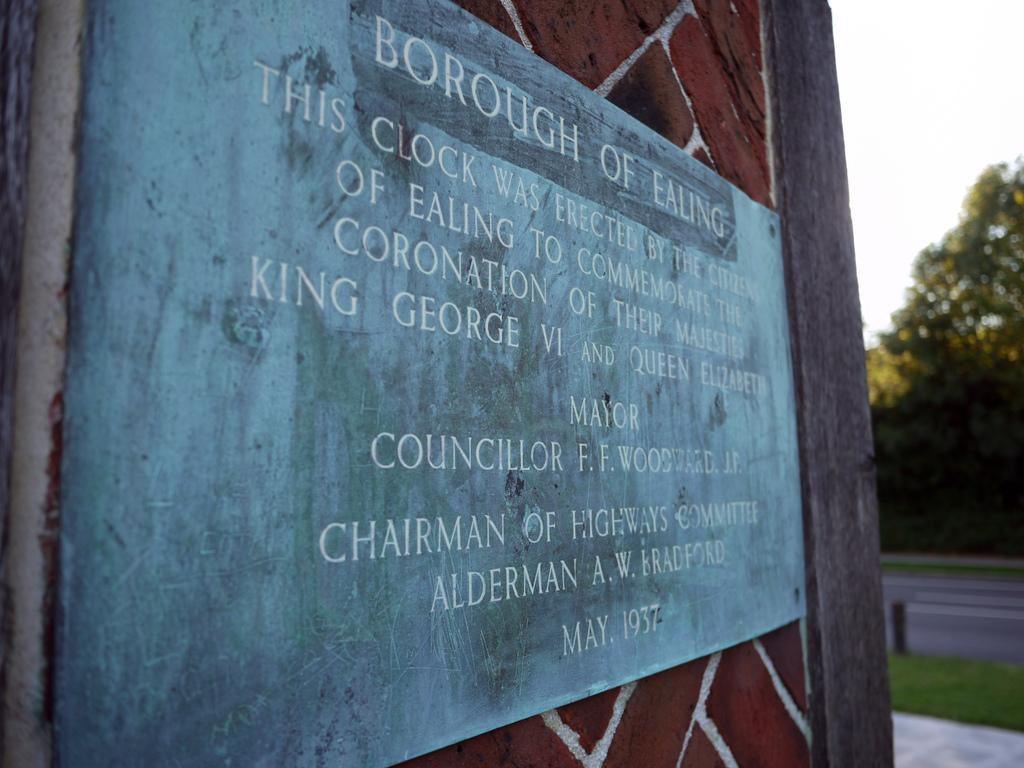<image>
Summarize the visual content of the image. the word chairman is on the front of the sign 